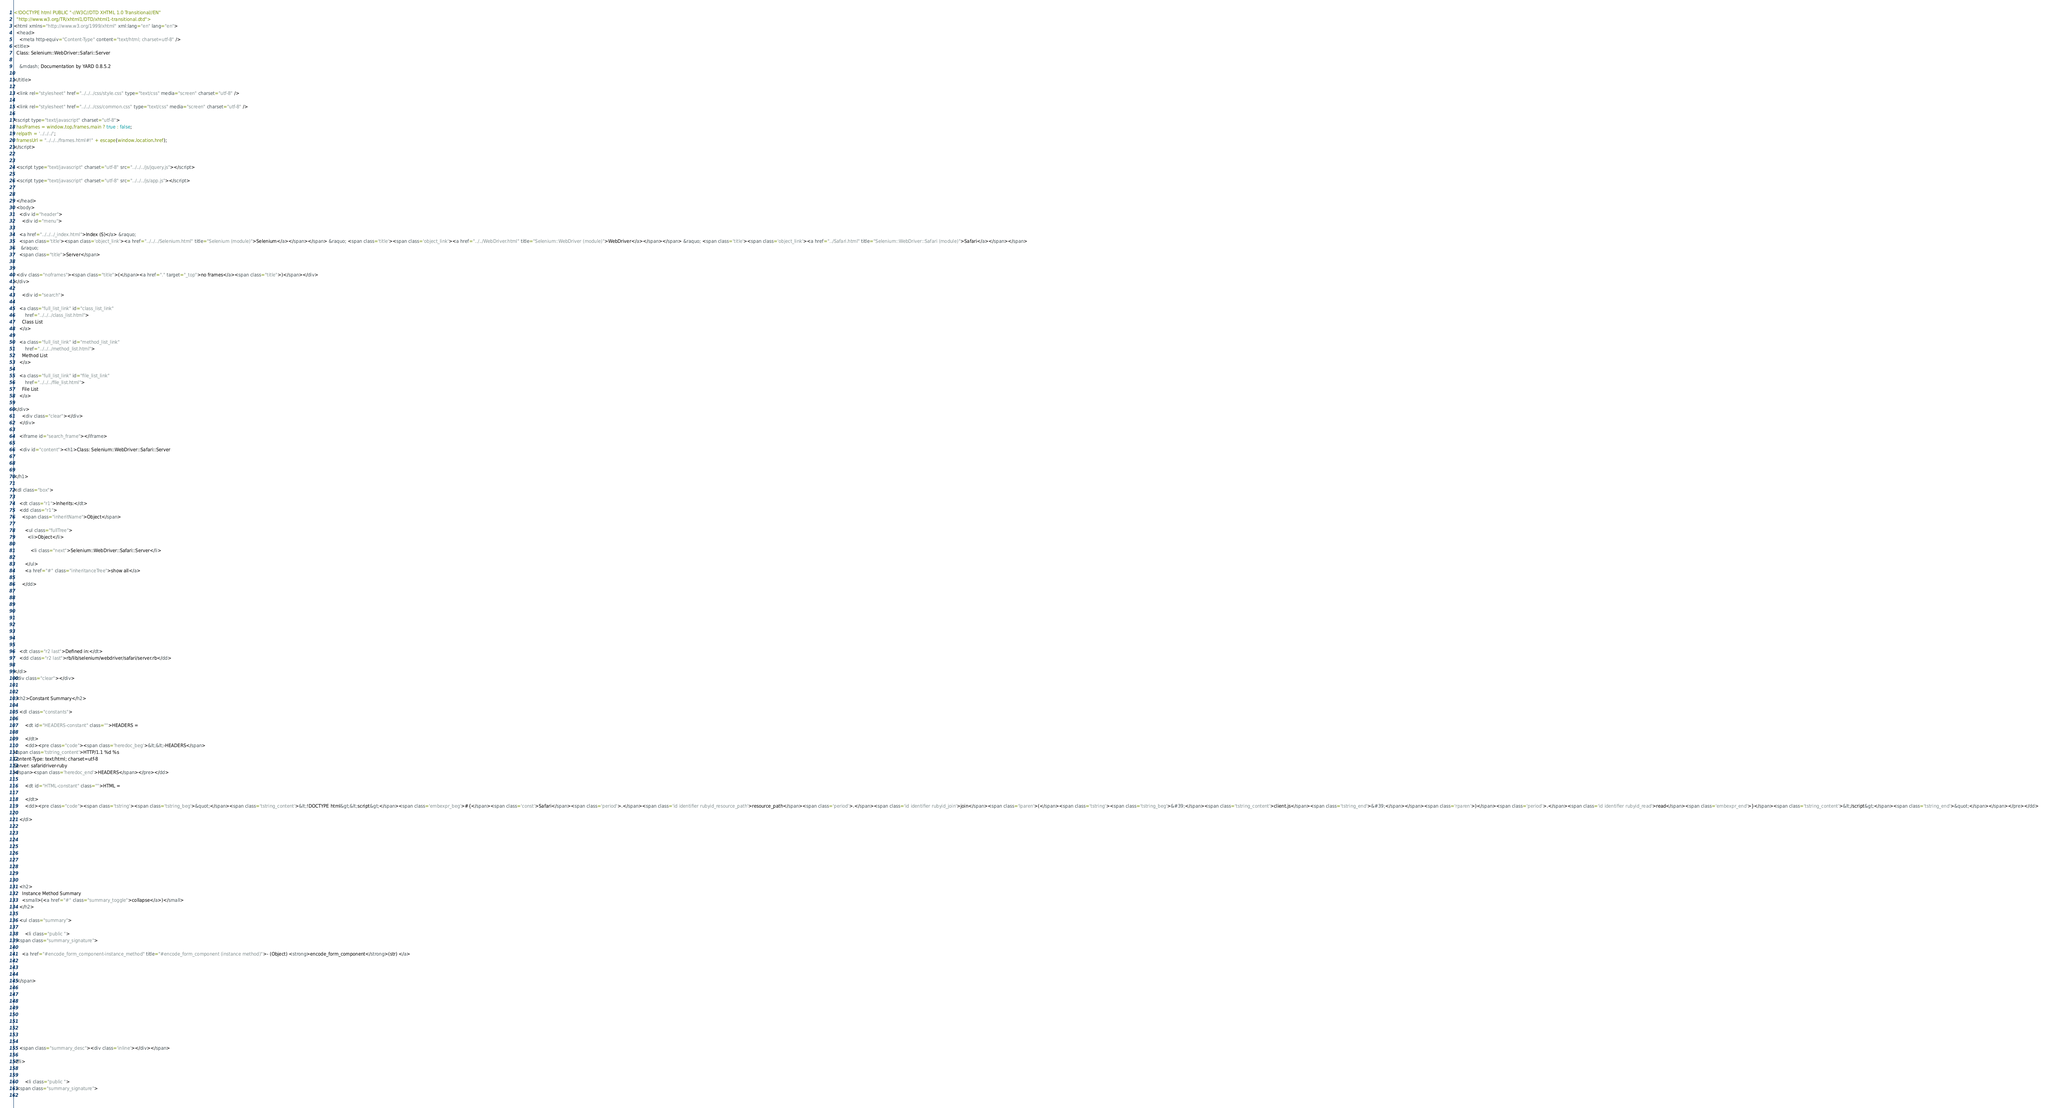<code> <loc_0><loc_0><loc_500><loc_500><_HTML_><!DOCTYPE html PUBLIC "-//W3C//DTD XHTML 1.0 Transitional//EN"
  "http://www.w3.org/TR/xhtml1/DTD/xhtml1-transitional.dtd">
<html xmlns="http://www.w3.org/1999/xhtml" xml:lang="en" lang="en">
  <head>
    <meta http-equiv="Content-Type" content="text/html; charset=utf-8" />
<title>
  Class: Selenium::WebDriver::Safari::Server
  
    &mdash; Documentation by YARD 0.8.5.2
  
</title>

  <link rel="stylesheet" href="../../../css/style.css" type="text/css" media="screen" charset="utf-8" />

  <link rel="stylesheet" href="../../../css/common.css" type="text/css" media="screen" charset="utf-8" />

<script type="text/javascript" charset="utf-8">
  hasFrames = window.top.frames.main ? true : false;
  relpath = '../../../';
  framesUrl = "../../../frames.html#!" + escape(window.location.href);
</script>


  <script type="text/javascript" charset="utf-8" src="../../../js/jquery.js"></script>

  <script type="text/javascript" charset="utf-8" src="../../../js/app.js"></script>


  </head>
  <body>
    <div id="header">
      <div id="menu">
  
    <a href="../../../_index.html">Index (S)</a> &raquo;
    <span class='title'><span class='object_link'><a href="../../../Selenium.html" title="Selenium (module)">Selenium</a></span></span> &raquo; <span class='title'><span class='object_link'><a href="../../WebDriver.html" title="Selenium::WebDriver (module)">WebDriver</a></span></span> &raquo; <span class='title'><span class='object_link'><a href="../Safari.html" title="Selenium::WebDriver::Safari (module)">Safari</a></span></span>
     &raquo; 
    <span class="title">Server</span>
  

  <div class="noframes"><span class="title">(</span><a href="." target="_top">no frames</a><span class="title">)</span></div>
</div>

      <div id="search">
  
    <a class="full_list_link" id="class_list_link"
        href="../../../class_list.html">
      Class List
    </a>
  
    <a class="full_list_link" id="method_list_link"
        href="../../../method_list.html">
      Method List
    </a>
  
    <a class="full_list_link" id="file_list_link"
        href="../../../file_list.html">
      File List
    </a>
  
</div>
      <div class="clear"></div>
    </div>

    <iframe id="search_frame"></iframe>

    <div id="content"><h1>Class: Selenium::WebDriver::Safari::Server
  
  
  
</h1>

<dl class="box">
  
    <dt class="r1">Inherits:</dt>
    <dd class="r1">
      <span class="inheritName">Object</span>
      
        <ul class="fullTree">
          <li>Object</li>
          
            <li class="next">Selenium::WebDriver::Safari::Server</li>
          
        </ul>
        <a href="#" class="inheritanceTree">show all</a>
      
      </dd>
    
  
  
    
  
    
  
  
  
    <dt class="r2 last">Defined in:</dt>
    <dd class="r2 last">rb/lib/selenium/webdriver/safari/server.rb</dd>
  
</dl>
<div class="clear"></div>


  <h2>Constant Summary</h2>
  
    <dl class="constants">
      
        <dt id="HEADERS-constant" class="">HEADERS =
          
        </dt>
        <dd><pre class="code"><span class='heredoc_beg'>&lt;&lt;-HEADERS</span>
<span class='tstring_content'>HTTP/1.1 %d %s
Content-Type: text/html; charset=utf-8
Server: safaridriver-ruby
</span><span class='heredoc_end'>HEADERS</span></pre></dd>
      
        <dt id="HTML-constant" class="">HTML =
          
        </dt>
        <dd><pre class="code"><span class='tstring'><span class='tstring_beg'>&quot;</span><span class='tstring_content'>&lt;!DOCTYPE html&gt;&lt;script&gt;</span><span class='embexpr_beg'>#{</span><span class='const'>Safari</span><span class='period'>.</span><span class='id identifier rubyid_resource_path'>resource_path</span><span class='period'>.</span><span class='id identifier rubyid_join'>join</span><span class='lparen'>(</span><span class='tstring'><span class='tstring_beg'>&#39;</span><span class='tstring_content'>client.js</span><span class='tstring_end'>&#39;</span></span><span class='rparen'>)</span><span class='period'>.</span><span class='id identifier rubyid_read'>read</span><span class='embexpr_end'>}</span><span class='tstring_content'>&lt;/script&gt;</span><span class='tstring_end'>&quot;</span></span></pre></dd>
      
    </dl>
  







  
    <h2>
      Instance Method Summary
      <small>(<a href="#" class="summary_toggle">collapse</a>)</small>
    </h2>

    <ul class="summary">
      
        <li class="public ">
  <span class="summary_signature">
    
      <a href="#encode_form_component-instance_method" title="#encode_form_component (instance method)">- (Object) <strong>encode_form_component</strong>(str) </a>
    

    
  </span>
  
  
  
  
  
  
  

  
    <span class="summary_desc"><div class='inline'></div></span>
  
</li>

      
        <li class="public ">
  <span class="summary_signature">
    </code> 